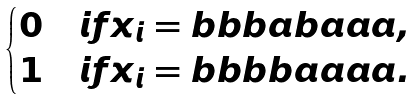Convert formula to latex. <formula><loc_0><loc_0><loc_500><loc_500>\begin{cases} 0 & i f x _ { i } = b b b a b a a a , \\ 1 & i f x _ { i } = b b b b a a a a . \end{cases}</formula> 